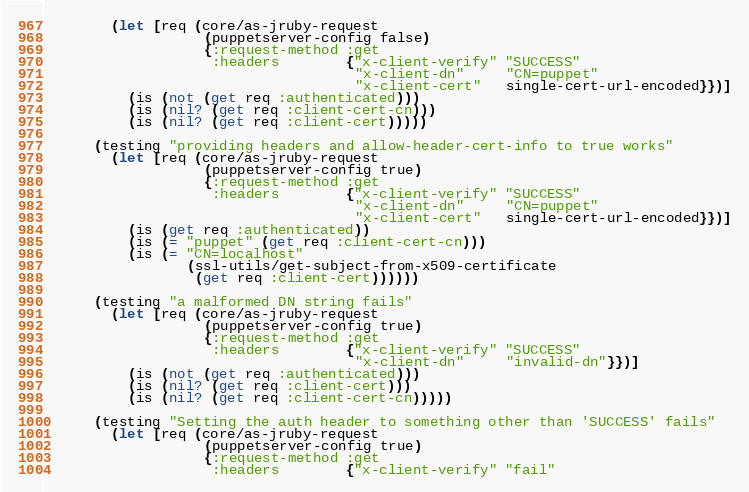<code> <loc_0><loc_0><loc_500><loc_500><_Clojure_>        (let [req (core/as-jruby-request
                   (puppetserver-config false)
                   {:request-method :get
                    :headers        {"x-client-verify" "SUCCESS"
                                     "x-client-dn"     "CN=puppet"
                                     "x-client-cert"   single-cert-url-encoded}})]
          (is (not (get req :authenticated)))
          (is (nil? (get req :client-cert-cn)))
          (is (nil? (get req :client-cert)))))

      (testing "providing headers and allow-header-cert-info to true works"
        (let [req (core/as-jruby-request
                   (puppetserver-config true)
                   {:request-method :get
                    :headers        {"x-client-verify" "SUCCESS"
                                     "x-client-dn"     "CN=puppet"
                                     "x-client-cert"   single-cert-url-encoded}})]
          (is (get req :authenticated))
          (is (= "puppet" (get req :client-cert-cn)))
          (is (= "CN=localhost"
                 (ssl-utils/get-subject-from-x509-certificate
                  (get req :client-cert))))))

      (testing "a malformed DN string fails"
        (let [req (core/as-jruby-request
                   (puppetserver-config true)
                   {:request-method :get
                    :headers        {"x-client-verify" "SUCCESS"
                                     "x-client-dn"     "invalid-dn"}})]
          (is (not (get req :authenticated)))
          (is (nil? (get req :client-cert)))
          (is (nil? (get req :client-cert-cn)))))

      (testing "Setting the auth header to something other than 'SUCCESS' fails"
        (let [req (core/as-jruby-request
                   (puppetserver-config true)
                   {:request-method :get
                    :headers        {"x-client-verify" "fail"</code> 